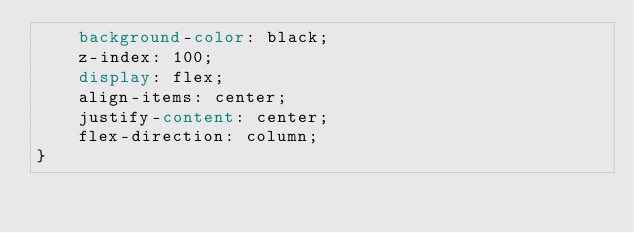<code> <loc_0><loc_0><loc_500><loc_500><_CSS_>    background-color: black;
    z-index: 100;
    display: flex;
    align-items: center;
    justify-content: center;
    flex-direction: column;
}</code> 